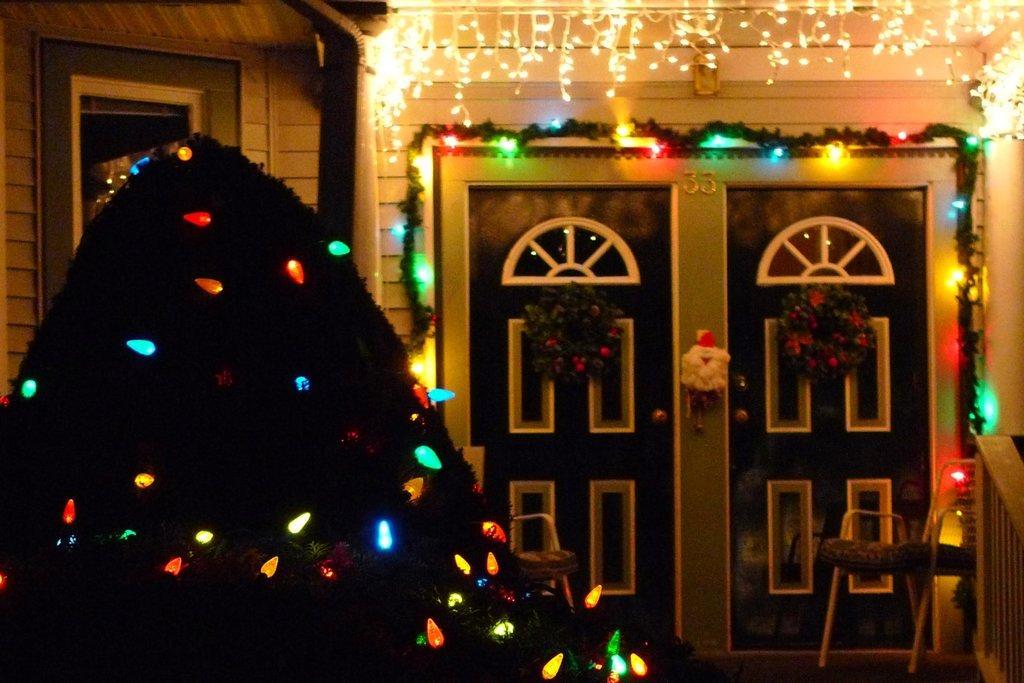How would you summarize this image in a sentence or two? In this image we can see wreaths to the doors and decor lights to the walls. 